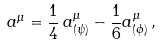<formula> <loc_0><loc_0><loc_500><loc_500>a ^ { \mu } = \frac { 1 } { 4 } \, a _ { ( \psi ) } ^ { \mu } - \frac { 1 } { 6 } a _ { ( \phi ) } ^ { \mu } \, ,</formula> 